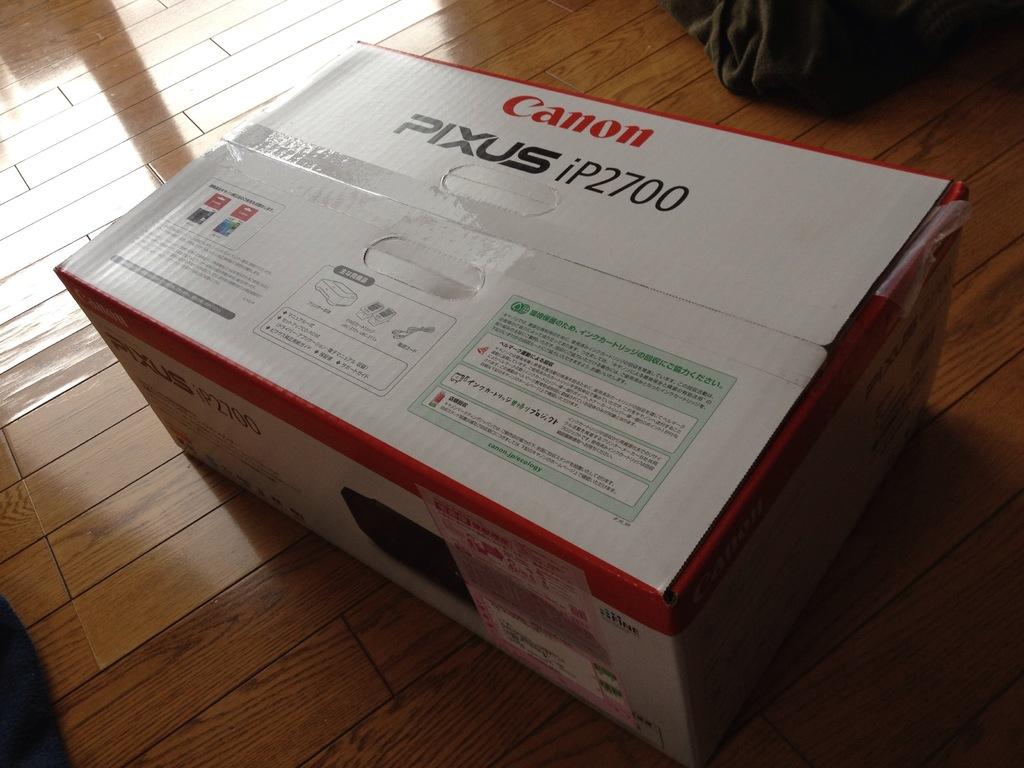What brand is the camera?
Offer a terse response. Canon. 